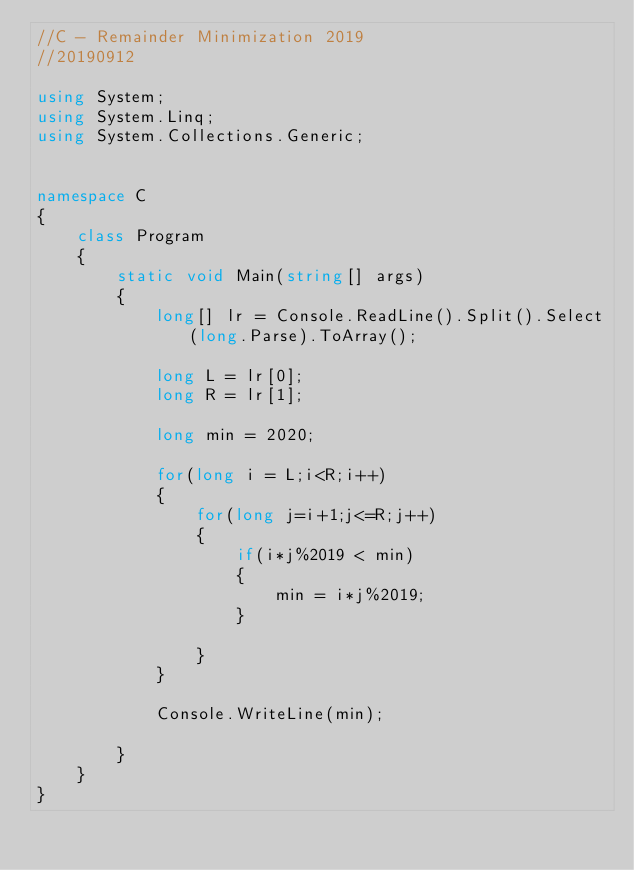Convert code to text. <code><loc_0><loc_0><loc_500><loc_500><_C#_>//C - Remainder Minimization 2019
//20190912

using System;
using System.Linq;
using System.Collections.Generic;


namespace C
{
    class Program
    {
        static void Main(string[] args)
        {
            long[] lr = Console.ReadLine().Split().Select(long.Parse).ToArray();

            long L = lr[0];
            long R = lr[1];
            
            long min = 2020;

            for(long i = L;i<R;i++)
            {
                for(long j=i+1;j<=R;j++)
                {
                    if(i*j%2019 < min)
                    {
                        min = i*j%2019;
                    }

                }
            }

            Console.WriteLine(min);

        }
    }
}
</code> 